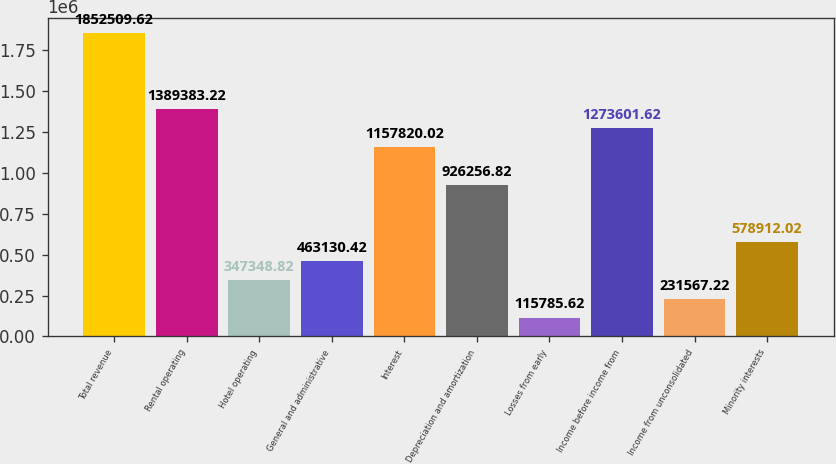<chart> <loc_0><loc_0><loc_500><loc_500><bar_chart><fcel>Total revenue<fcel>Rental operating<fcel>Hotel operating<fcel>General and administrative<fcel>Interest<fcel>Depreciation and amortization<fcel>Losses from early<fcel>Income before income from<fcel>Income from unconsolidated<fcel>Minority interests<nl><fcel>1.85251e+06<fcel>1.38938e+06<fcel>347349<fcel>463130<fcel>1.15782e+06<fcel>926257<fcel>115786<fcel>1.2736e+06<fcel>231567<fcel>578912<nl></chart> 